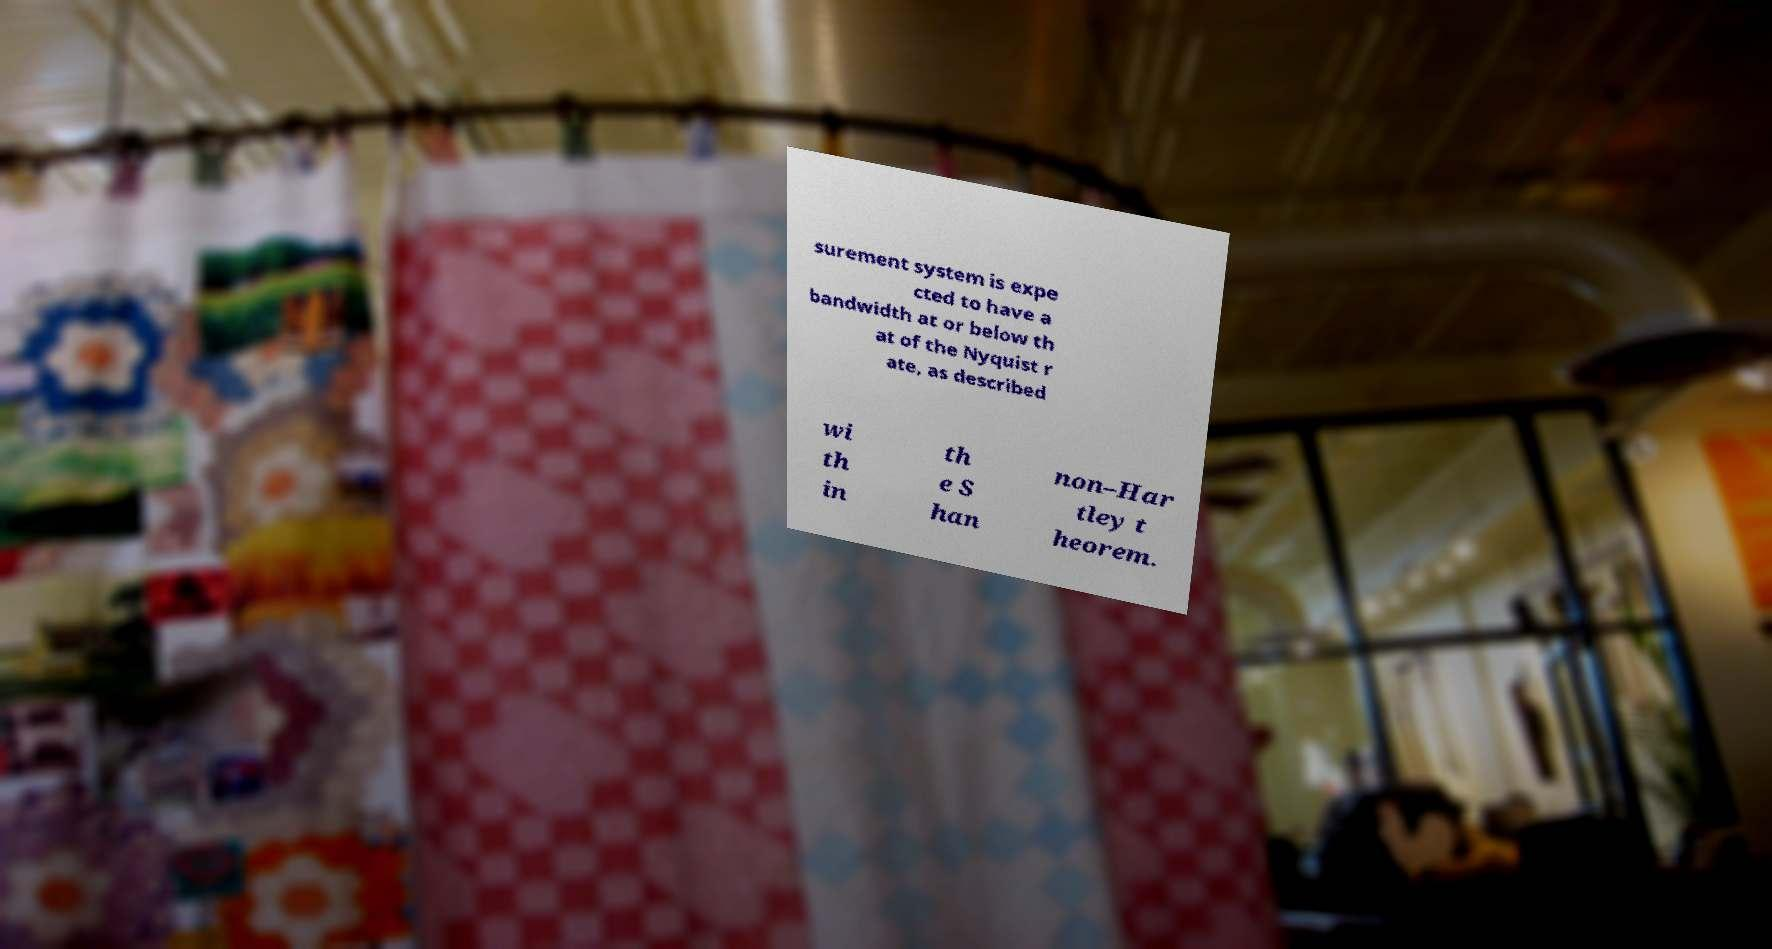There's text embedded in this image that I need extracted. Can you transcribe it verbatim? surement system is expe cted to have a bandwidth at or below th at of the Nyquist r ate, as described wi th in th e S han non–Har tley t heorem. 